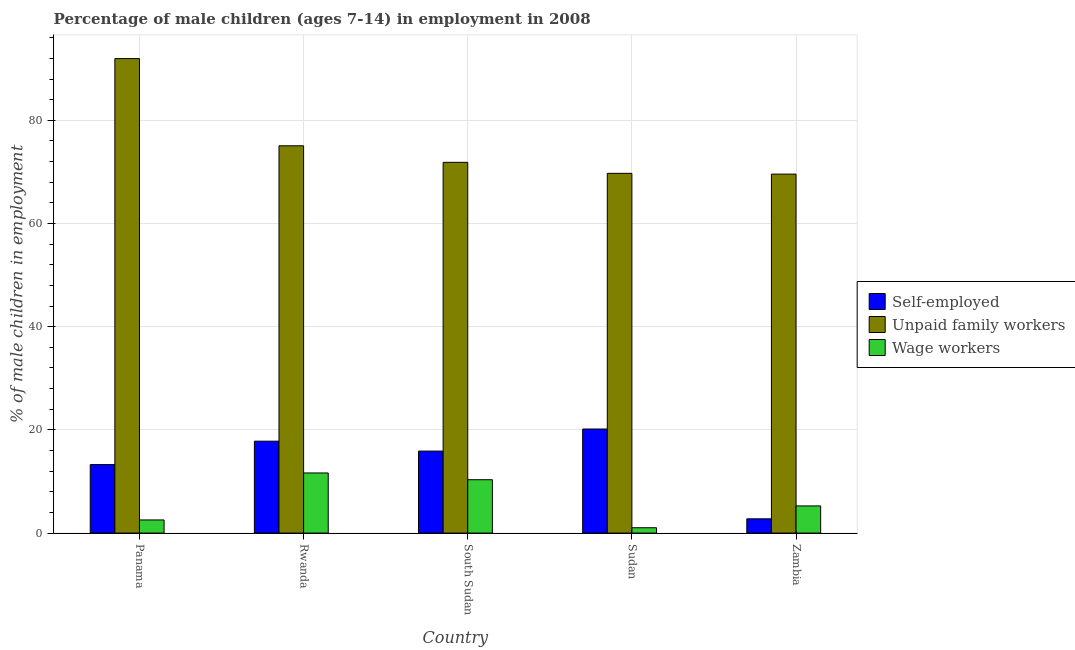How many different coloured bars are there?
Provide a short and direct response. 3. How many groups of bars are there?
Offer a very short reply. 5. Are the number of bars on each tick of the X-axis equal?
Keep it short and to the point. Yes. What is the label of the 4th group of bars from the left?
Your response must be concise. Sudan. In how many cases, is the number of bars for a given country not equal to the number of legend labels?
Your answer should be very brief. 0. What is the percentage of children employed as unpaid family workers in Sudan?
Ensure brevity in your answer.  69.73. Across all countries, what is the maximum percentage of children employed as wage workers?
Your answer should be very brief. 11.65. Across all countries, what is the minimum percentage of children employed as wage workers?
Ensure brevity in your answer.  1.03. In which country was the percentage of children employed as unpaid family workers maximum?
Provide a succinct answer. Panama. In which country was the percentage of children employed as wage workers minimum?
Your response must be concise. Sudan. What is the total percentage of children employed as unpaid family workers in the graph?
Ensure brevity in your answer.  378.21. What is the difference between the percentage of self employed children in Sudan and that in Zambia?
Provide a short and direct response. 17.41. What is the difference between the percentage of children employed as wage workers in Rwanda and the percentage of children employed as unpaid family workers in Panama?
Your answer should be compact. -80.32. What is the average percentage of children employed as wage workers per country?
Your response must be concise. 6.16. What is the difference between the percentage of self employed children and percentage of children employed as unpaid family workers in Zambia?
Make the answer very short. -66.82. In how many countries, is the percentage of self employed children greater than 68 %?
Provide a short and direct response. 0. What is the ratio of the percentage of children employed as wage workers in Rwanda to that in South Sudan?
Offer a terse response. 1.13. Is the percentage of children employed as wage workers in Rwanda less than that in Zambia?
Give a very brief answer. No. What is the difference between the highest and the second highest percentage of children employed as wage workers?
Offer a very short reply. 1.31. What is the difference between the highest and the lowest percentage of self employed children?
Your answer should be very brief. 17.41. In how many countries, is the percentage of children employed as unpaid family workers greater than the average percentage of children employed as unpaid family workers taken over all countries?
Provide a succinct answer. 1. What does the 3rd bar from the left in Rwanda represents?
Offer a terse response. Wage workers. What does the 1st bar from the right in Sudan represents?
Offer a very short reply. Wage workers. How many bars are there?
Give a very brief answer. 15. What is the difference between two consecutive major ticks on the Y-axis?
Offer a terse response. 20. Does the graph contain any zero values?
Your response must be concise. No. Does the graph contain grids?
Ensure brevity in your answer.  Yes. How many legend labels are there?
Provide a succinct answer. 3. What is the title of the graph?
Provide a short and direct response. Percentage of male children (ages 7-14) in employment in 2008. What is the label or title of the Y-axis?
Provide a succinct answer. % of male children in employment. What is the % of male children in employment in Self-employed in Panama?
Keep it short and to the point. 13.27. What is the % of male children in employment in Unpaid family workers in Panama?
Provide a succinct answer. 91.97. What is the % of male children in employment of Wage workers in Panama?
Your answer should be compact. 2.54. What is the % of male children in employment of Self-employed in Rwanda?
Make the answer very short. 17.81. What is the % of male children in employment of Unpaid family workers in Rwanda?
Keep it short and to the point. 75.07. What is the % of male children in employment in Wage workers in Rwanda?
Offer a very short reply. 11.65. What is the % of male children in employment of Self-employed in South Sudan?
Give a very brief answer. 15.89. What is the % of male children in employment in Unpaid family workers in South Sudan?
Your answer should be compact. 71.86. What is the % of male children in employment in Wage workers in South Sudan?
Make the answer very short. 10.34. What is the % of male children in employment of Self-employed in Sudan?
Provide a short and direct response. 20.17. What is the % of male children in employment in Unpaid family workers in Sudan?
Offer a terse response. 69.73. What is the % of male children in employment of Self-employed in Zambia?
Your response must be concise. 2.76. What is the % of male children in employment of Unpaid family workers in Zambia?
Give a very brief answer. 69.58. What is the % of male children in employment of Wage workers in Zambia?
Provide a succinct answer. 5.26. Across all countries, what is the maximum % of male children in employment in Self-employed?
Make the answer very short. 20.17. Across all countries, what is the maximum % of male children in employment of Unpaid family workers?
Ensure brevity in your answer.  91.97. Across all countries, what is the maximum % of male children in employment in Wage workers?
Your answer should be compact. 11.65. Across all countries, what is the minimum % of male children in employment in Self-employed?
Offer a very short reply. 2.76. Across all countries, what is the minimum % of male children in employment of Unpaid family workers?
Make the answer very short. 69.58. Across all countries, what is the minimum % of male children in employment in Wage workers?
Offer a terse response. 1.03. What is the total % of male children in employment in Self-employed in the graph?
Ensure brevity in your answer.  69.9. What is the total % of male children in employment of Unpaid family workers in the graph?
Offer a very short reply. 378.21. What is the total % of male children in employment of Wage workers in the graph?
Give a very brief answer. 30.82. What is the difference between the % of male children in employment in Self-employed in Panama and that in Rwanda?
Keep it short and to the point. -4.54. What is the difference between the % of male children in employment of Unpaid family workers in Panama and that in Rwanda?
Ensure brevity in your answer.  16.9. What is the difference between the % of male children in employment in Wage workers in Panama and that in Rwanda?
Give a very brief answer. -9.11. What is the difference between the % of male children in employment in Self-employed in Panama and that in South Sudan?
Give a very brief answer. -2.62. What is the difference between the % of male children in employment of Unpaid family workers in Panama and that in South Sudan?
Give a very brief answer. 20.11. What is the difference between the % of male children in employment of Self-employed in Panama and that in Sudan?
Provide a short and direct response. -6.9. What is the difference between the % of male children in employment in Unpaid family workers in Panama and that in Sudan?
Give a very brief answer. 22.24. What is the difference between the % of male children in employment in Wage workers in Panama and that in Sudan?
Keep it short and to the point. 1.51. What is the difference between the % of male children in employment of Self-employed in Panama and that in Zambia?
Provide a succinct answer. 10.51. What is the difference between the % of male children in employment of Unpaid family workers in Panama and that in Zambia?
Give a very brief answer. 22.39. What is the difference between the % of male children in employment of Wage workers in Panama and that in Zambia?
Offer a terse response. -2.72. What is the difference between the % of male children in employment in Self-employed in Rwanda and that in South Sudan?
Give a very brief answer. 1.92. What is the difference between the % of male children in employment of Unpaid family workers in Rwanda and that in South Sudan?
Ensure brevity in your answer.  3.21. What is the difference between the % of male children in employment in Wage workers in Rwanda and that in South Sudan?
Offer a very short reply. 1.31. What is the difference between the % of male children in employment of Self-employed in Rwanda and that in Sudan?
Your answer should be very brief. -2.36. What is the difference between the % of male children in employment in Unpaid family workers in Rwanda and that in Sudan?
Provide a succinct answer. 5.34. What is the difference between the % of male children in employment in Wage workers in Rwanda and that in Sudan?
Give a very brief answer. 10.62. What is the difference between the % of male children in employment in Self-employed in Rwanda and that in Zambia?
Provide a short and direct response. 15.05. What is the difference between the % of male children in employment in Unpaid family workers in Rwanda and that in Zambia?
Your response must be concise. 5.49. What is the difference between the % of male children in employment of Wage workers in Rwanda and that in Zambia?
Ensure brevity in your answer.  6.39. What is the difference between the % of male children in employment of Self-employed in South Sudan and that in Sudan?
Offer a very short reply. -4.28. What is the difference between the % of male children in employment of Unpaid family workers in South Sudan and that in Sudan?
Make the answer very short. 2.13. What is the difference between the % of male children in employment in Wage workers in South Sudan and that in Sudan?
Offer a terse response. 9.31. What is the difference between the % of male children in employment of Self-employed in South Sudan and that in Zambia?
Make the answer very short. 13.13. What is the difference between the % of male children in employment of Unpaid family workers in South Sudan and that in Zambia?
Offer a terse response. 2.28. What is the difference between the % of male children in employment in Wage workers in South Sudan and that in Zambia?
Ensure brevity in your answer.  5.08. What is the difference between the % of male children in employment in Self-employed in Sudan and that in Zambia?
Offer a very short reply. 17.41. What is the difference between the % of male children in employment of Unpaid family workers in Sudan and that in Zambia?
Provide a succinct answer. 0.15. What is the difference between the % of male children in employment of Wage workers in Sudan and that in Zambia?
Your answer should be very brief. -4.23. What is the difference between the % of male children in employment of Self-employed in Panama and the % of male children in employment of Unpaid family workers in Rwanda?
Provide a short and direct response. -61.8. What is the difference between the % of male children in employment of Self-employed in Panama and the % of male children in employment of Wage workers in Rwanda?
Keep it short and to the point. 1.62. What is the difference between the % of male children in employment of Unpaid family workers in Panama and the % of male children in employment of Wage workers in Rwanda?
Your response must be concise. 80.32. What is the difference between the % of male children in employment in Self-employed in Panama and the % of male children in employment in Unpaid family workers in South Sudan?
Your response must be concise. -58.59. What is the difference between the % of male children in employment of Self-employed in Panama and the % of male children in employment of Wage workers in South Sudan?
Your answer should be very brief. 2.93. What is the difference between the % of male children in employment in Unpaid family workers in Panama and the % of male children in employment in Wage workers in South Sudan?
Offer a terse response. 81.63. What is the difference between the % of male children in employment in Self-employed in Panama and the % of male children in employment in Unpaid family workers in Sudan?
Your answer should be compact. -56.46. What is the difference between the % of male children in employment of Self-employed in Panama and the % of male children in employment of Wage workers in Sudan?
Ensure brevity in your answer.  12.24. What is the difference between the % of male children in employment of Unpaid family workers in Panama and the % of male children in employment of Wage workers in Sudan?
Your answer should be compact. 90.94. What is the difference between the % of male children in employment in Self-employed in Panama and the % of male children in employment in Unpaid family workers in Zambia?
Provide a succinct answer. -56.31. What is the difference between the % of male children in employment of Self-employed in Panama and the % of male children in employment of Wage workers in Zambia?
Give a very brief answer. 8.01. What is the difference between the % of male children in employment of Unpaid family workers in Panama and the % of male children in employment of Wage workers in Zambia?
Give a very brief answer. 86.71. What is the difference between the % of male children in employment of Self-employed in Rwanda and the % of male children in employment of Unpaid family workers in South Sudan?
Provide a succinct answer. -54.05. What is the difference between the % of male children in employment in Self-employed in Rwanda and the % of male children in employment in Wage workers in South Sudan?
Your response must be concise. 7.47. What is the difference between the % of male children in employment of Unpaid family workers in Rwanda and the % of male children in employment of Wage workers in South Sudan?
Ensure brevity in your answer.  64.73. What is the difference between the % of male children in employment of Self-employed in Rwanda and the % of male children in employment of Unpaid family workers in Sudan?
Your answer should be compact. -51.92. What is the difference between the % of male children in employment in Self-employed in Rwanda and the % of male children in employment in Wage workers in Sudan?
Your answer should be compact. 16.78. What is the difference between the % of male children in employment of Unpaid family workers in Rwanda and the % of male children in employment of Wage workers in Sudan?
Offer a terse response. 74.04. What is the difference between the % of male children in employment in Self-employed in Rwanda and the % of male children in employment in Unpaid family workers in Zambia?
Give a very brief answer. -51.77. What is the difference between the % of male children in employment in Self-employed in Rwanda and the % of male children in employment in Wage workers in Zambia?
Give a very brief answer. 12.55. What is the difference between the % of male children in employment of Unpaid family workers in Rwanda and the % of male children in employment of Wage workers in Zambia?
Make the answer very short. 69.81. What is the difference between the % of male children in employment in Self-employed in South Sudan and the % of male children in employment in Unpaid family workers in Sudan?
Offer a terse response. -53.84. What is the difference between the % of male children in employment in Self-employed in South Sudan and the % of male children in employment in Wage workers in Sudan?
Provide a short and direct response. 14.86. What is the difference between the % of male children in employment of Unpaid family workers in South Sudan and the % of male children in employment of Wage workers in Sudan?
Your response must be concise. 70.83. What is the difference between the % of male children in employment of Self-employed in South Sudan and the % of male children in employment of Unpaid family workers in Zambia?
Offer a terse response. -53.69. What is the difference between the % of male children in employment of Self-employed in South Sudan and the % of male children in employment of Wage workers in Zambia?
Your answer should be very brief. 10.63. What is the difference between the % of male children in employment of Unpaid family workers in South Sudan and the % of male children in employment of Wage workers in Zambia?
Give a very brief answer. 66.6. What is the difference between the % of male children in employment in Self-employed in Sudan and the % of male children in employment in Unpaid family workers in Zambia?
Offer a very short reply. -49.41. What is the difference between the % of male children in employment in Self-employed in Sudan and the % of male children in employment in Wage workers in Zambia?
Provide a short and direct response. 14.91. What is the difference between the % of male children in employment in Unpaid family workers in Sudan and the % of male children in employment in Wage workers in Zambia?
Your answer should be compact. 64.47. What is the average % of male children in employment in Self-employed per country?
Give a very brief answer. 13.98. What is the average % of male children in employment of Unpaid family workers per country?
Keep it short and to the point. 75.64. What is the average % of male children in employment in Wage workers per country?
Ensure brevity in your answer.  6.16. What is the difference between the % of male children in employment in Self-employed and % of male children in employment in Unpaid family workers in Panama?
Provide a succinct answer. -78.7. What is the difference between the % of male children in employment of Self-employed and % of male children in employment of Wage workers in Panama?
Make the answer very short. 10.73. What is the difference between the % of male children in employment in Unpaid family workers and % of male children in employment in Wage workers in Panama?
Provide a succinct answer. 89.43. What is the difference between the % of male children in employment of Self-employed and % of male children in employment of Unpaid family workers in Rwanda?
Your response must be concise. -57.26. What is the difference between the % of male children in employment in Self-employed and % of male children in employment in Wage workers in Rwanda?
Offer a terse response. 6.16. What is the difference between the % of male children in employment in Unpaid family workers and % of male children in employment in Wage workers in Rwanda?
Provide a short and direct response. 63.42. What is the difference between the % of male children in employment in Self-employed and % of male children in employment in Unpaid family workers in South Sudan?
Provide a succinct answer. -55.97. What is the difference between the % of male children in employment in Self-employed and % of male children in employment in Wage workers in South Sudan?
Your answer should be very brief. 5.55. What is the difference between the % of male children in employment in Unpaid family workers and % of male children in employment in Wage workers in South Sudan?
Your response must be concise. 61.52. What is the difference between the % of male children in employment of Self-employed and % of male children in employment of Unpaid family workers in Sudan?
Your answer should be very brief. -49.56. What is the difference between the % of male children in employment of Self-employed and % of male children in employment of Wage workers in Sudan?
Offer a very short reply. 19.14. What is the difference between the % of male children in employment in Unpaid family workers and % of male children in employment in Wage workers in Sudan?
Ensure brevity in your answer.  68.7. What is the difference between the % of male children in employment of Self-employed and % of male children in employment of Unpaid family workers in Zambia?
Your answer should be compact. -66.82. What is the difference between the % of male children in employment of Self-employed and % of male children in employment of Wage workers in Zambia?
Ensure brevity in your answer.  -2.5. What is the difference between the % of male children in employment of Unpaid family workers and % of male children in employment of Wage workers in Zambia?
Provide a short and direct response. 64.32. What is the ratio of the % of male children in employment in Self-employed in Panama to that in Rwanda?
Provide a succinct answer. 0.75. What is the ratio of the % of male children in employment of Unpaid family workers in Panama to that in Rwanda?
Your response must be concise. 1.23. What is the ratio of the % of male children in employment in Wage workers in Panama to that in Rwanda?
Offer a very short reply. 0.22. What is the ratio of the % of male children in employment in Self-employed in Panama to that in South Sudan?
Your answer should be compact. 0.84. What is the ratio of the % of male children in employment in Unpaid family workers in Panama to that in South Sudan?
Give a very brief answer. 1.28. What is the ratio of the % of male children in employment in Wage workers in Panama to that in South Sudan?
Make the answer very short. 0.25. What is the ratio of the % of male children in employment in Self-employed in Panama to that in Sudan?
Offer a terse response. 0.66. What is the ratio of the % of male children in employment of Unpaid family workers in Panama to that in Sudan?
Provide a succinct answer. 1.32. What is the ratio of the % of male children in employment in Wage workers in Panama to that in Sudan?
Keep it short and to the point. 2.47. What is the ratio of the % of male children in employment of Self-employed in Panama to that in Zambia?
Provide a short and direct response. 4.81. What is the ratio of the % of male children in employment in Unpaid family workers in Panama to that in Zambia?
Provide a succinct answer. 1.32. What is the ratio of the % of male children in employment in Wage workers in Panama to that in Zambia?
Offer a very short reply. 0.48. What is the ratio of the % of male children in employment in Self-employed in Rwanda to that in South Sudan?
Provide a short and direct response. 1.12. What is the ratio of the % of male children in employment in Unpaid family workers in Rwanda to that in South Sudan?
Keep it short and to the point. 1.04. What is the ratio of the % of male children in employment in Wage workers in Rwanda to that in South Sudan?
Your answer should be very brief. 1.13. What is the ratio of the % of male children in employment in Self-employed in Rwanda to that in Sudan?
Your response must be concise. 0.88. What is the ratio of the % of male children in employment in Unpaid family workers in Rwanda to that in Sudan?
Keep it short and to the point. 1.08. What is the ratio of the % of male children in employment in Wage workers in Rwanda to that in Sudan?
Ensure brevity in your answer.  11.31. What is the ratio of the % of male children in employment of Self-employed in Rwanda to that in Zambia?
Your answer should be very brief. 6.45. What is the ratio of the % of male children in employment of Unpaid family workers in Rwanda to that in Zambia?
Provide a succinct answer. 1.08. What is the ratio of the % of male children in employment in Wage workers in Rwanda to that in Zambia?
Ensure brevity in your answer.  2.21. What is the ratio of the % of male children in employment in Self-employed in South Sudan to that in Sudan?
Provide a short and direct response. 0.79. What is the ratio of the % of male children in employment of Unpaid family workers in South Sudan to that in Sudan?
Provide a short and direct response. 1.03. What is the ratio of the % of male children in employment of Wage workers in South Sudan to that in Sudan?
Ensure brevity in your answer.  10.04. What is the ratio of the % of male children in employment in Self-employed in South Sudan to that in Zambia?
Your answer should be very brief. 5.76. What is the ratio of the % of male children in employment of Unpaid family workers in South Sudan to that in Zambia?
Provide a succinct answer. 1.03. What is the ratio of the % of male children in employment in Wage workers in South Sudan to that in Zambia?
Provide a succinct answer. 1.97. What is the ratio of the % of male children in employment in Self-employed in Sudan to that in Zambia?
Offer a very short reply. 7.31. What is the ratio of the % of male children in employment of Wage workers in Sudan to that in Zambia?
Your answer should be compact. 0.2. What is the difference between the highest and the second highest % of male children in employment of Self-employed?
Make the answer very short. 2.36. What is the difference between the highest and the second highest % of male children in employment in Wage workers?
Your answer should be very brief. 1.31. What is the difference between the highest and the lowest % of male children in employment of Self-employed?
Make the answer very short. 17.41. What is the difference between the highest and the lowest % of male children in employment of Unpaid family workers?
Ensure brevity in your answer.  22.39. What is the difference between the highest and the lowest % of male children in employment of Wage workers?
Offer a very short reply. 10.62. 